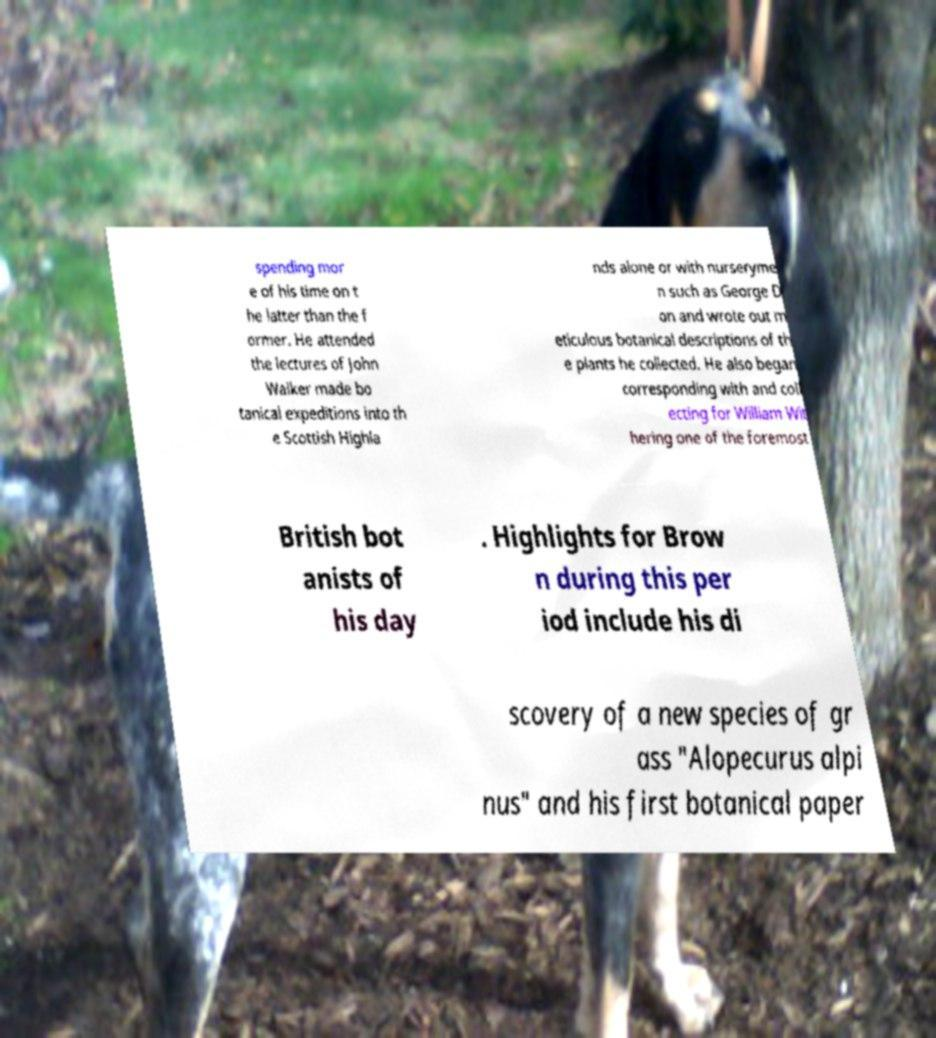What messages or text are displayed in this image? I need them in a readable, typed format. spending mor e of his time on t he latter than the f ormer. He attended the lectures of John Walker made bo tanical expeditions into th e Scottish Highla nds alone or with nurseryme n such as George D on and wrote out m eticulous botanical descriptions of th e plants he collected. He also began corresponding with and coll ecting for William Wit hering one of the foremost British bot anists of his day . Highlights for Brow n during this per iod include his di scovery of a new species of gr ass "Alopecurus alpi nus" and his first botanical paper 